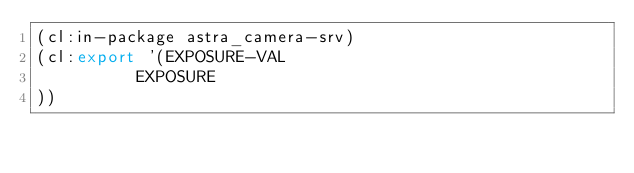<code> <loc_0><loc_0><loc_500><loc_500><_Lisp_>(cl:in-package astra_camera-srv)
(cl:export '(EXPOSURE-VAL
          EXPOSURE
))</code> 